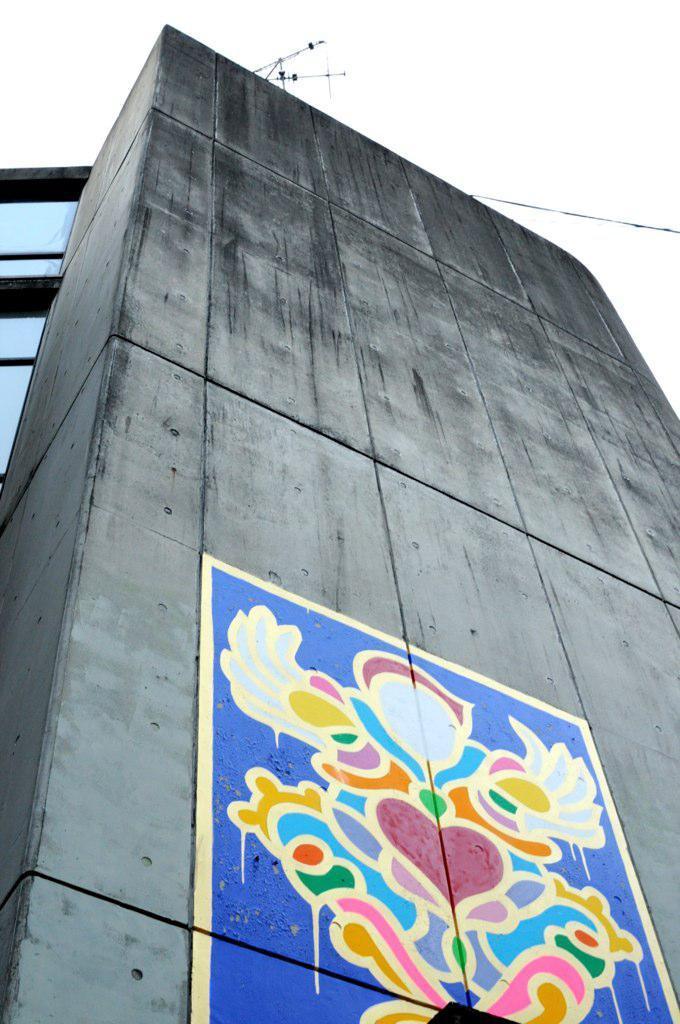Describe this image in one or two sentences. In this picture we can see a long grey color cement wall on which colorful design poster is stick. Above we can see a clear sky. 